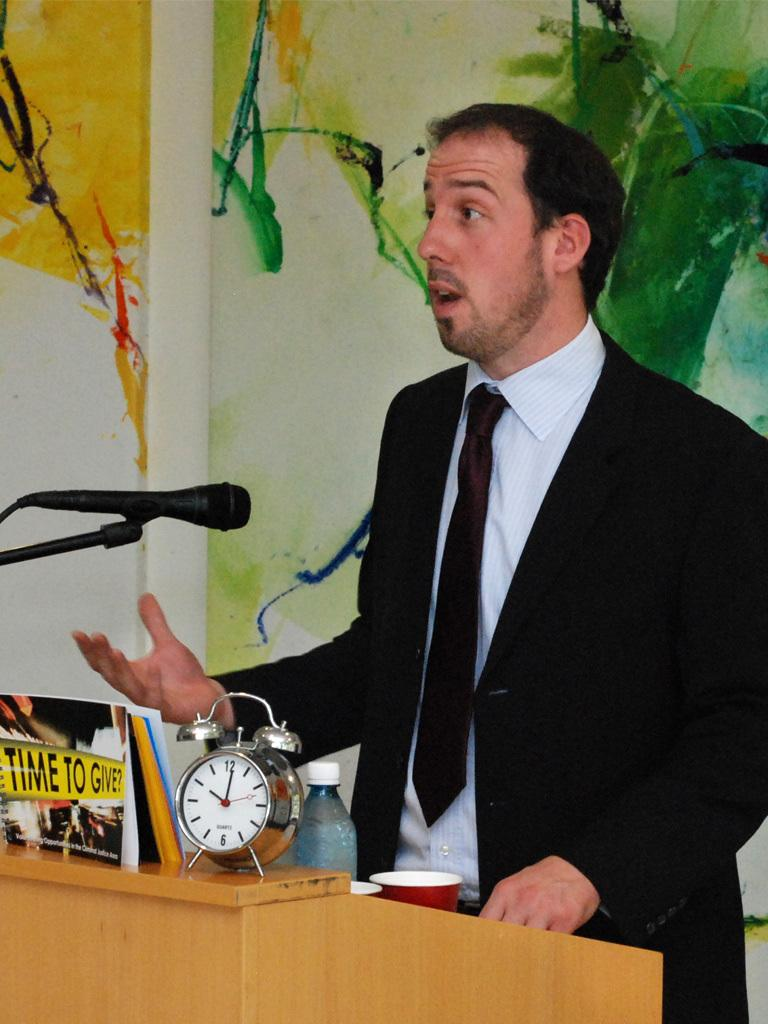<image>
Create a compact narrative representing the image presented. A man standing at a podium with a clock and a Time to Give picture. 